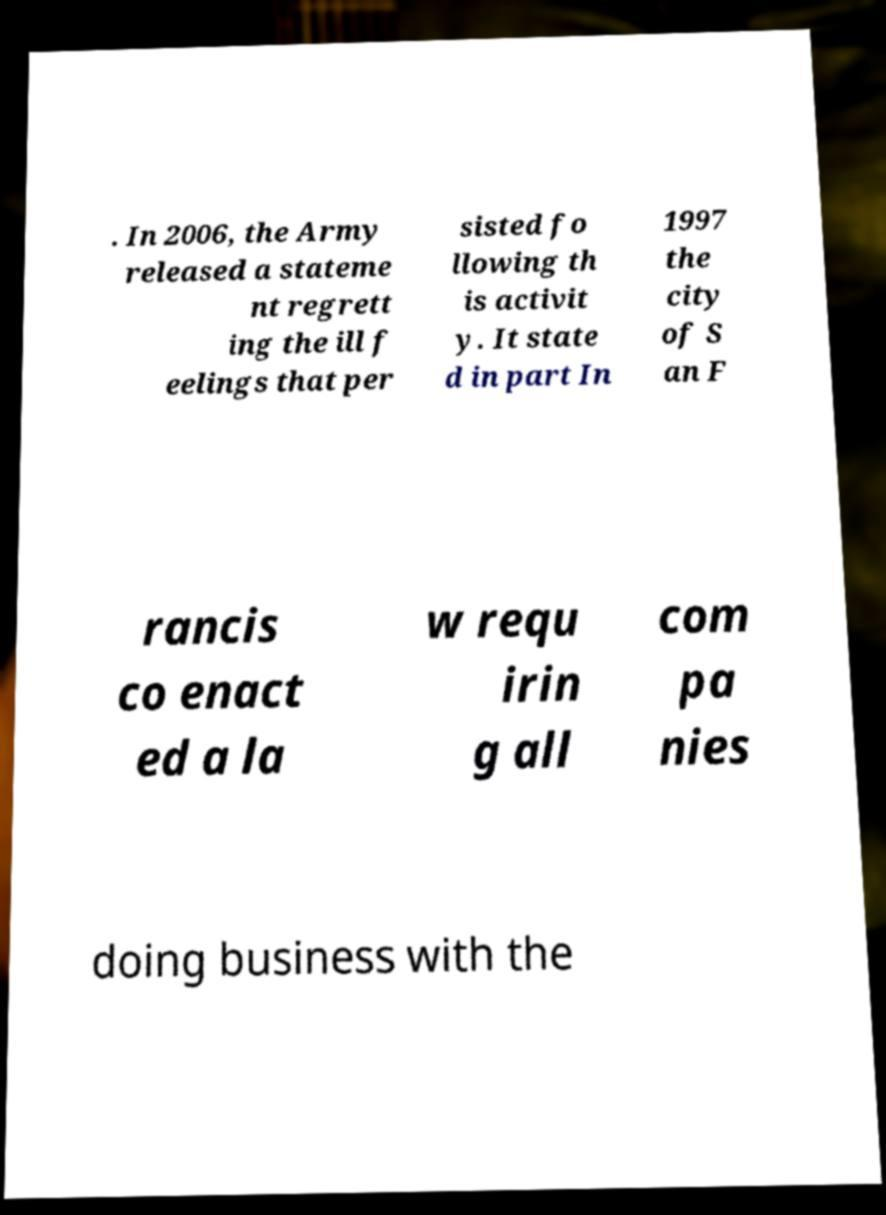Can you read and provide the text displayed in the image?This photo seems to have some interesting text. Can you extract and type it out for me? . In 2006, the Army released a stateme nt regrett ing the ill f eelings that per sisted fo llowing th is activit y. It state d in part In 1997 the city of S an F rancis co enact ed a la w requ irin g all com pa nies doing business with the 